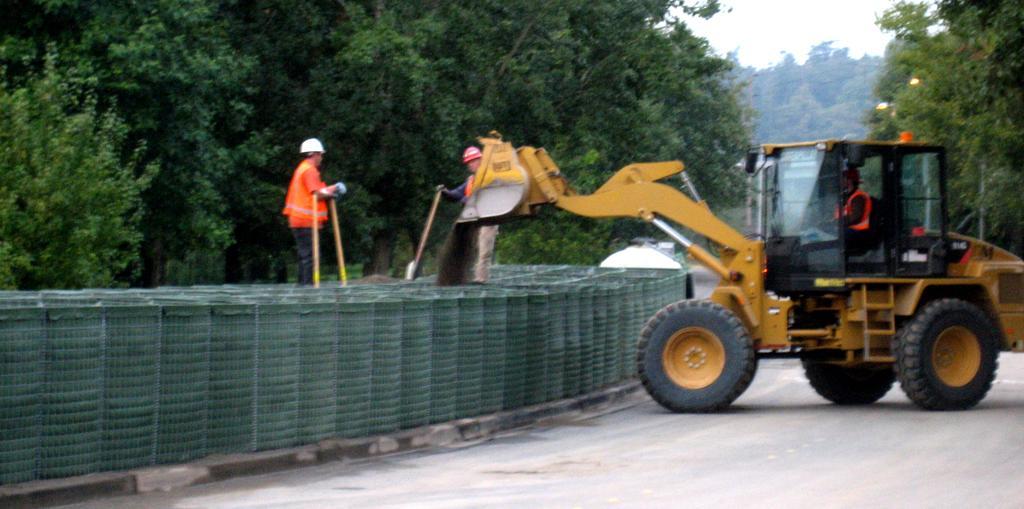Can you describe this image briefly? In this image we can see there are two people standing on the wall, behind them there is a proclainer on the road and so many trees at the back. 